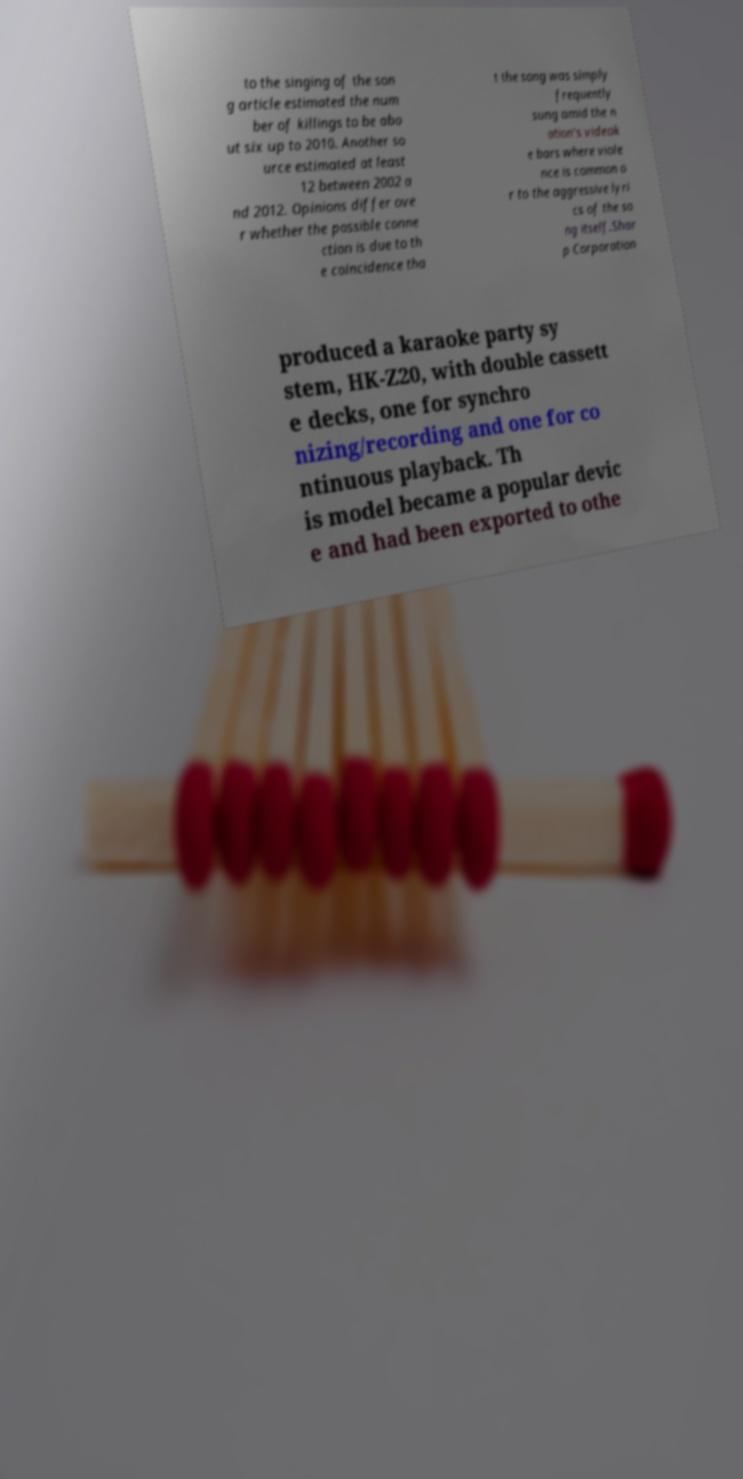I need the written content from this picture converted into text. Can you do that? to the singing of the son g article estimated the num ber of killings to be abo ut six up to 2010. Another so urce estimated at least 12 between 2002 a nd 2012. Opinions differ ove r whether the possible conne ction is due to th e coincidence tha t the song was simply frequently sung amid the n ation's videok e bars where viole nce is common o r to the aggressive lyri cs of the so ng itself.Shar p Corporation produced a karaoke party sy stem, HK-Z20, with double cassett e decks, one for synchro nizing/recording and one for co ntinuous playback. Th is model became a popular devic e and had been exported to othe 